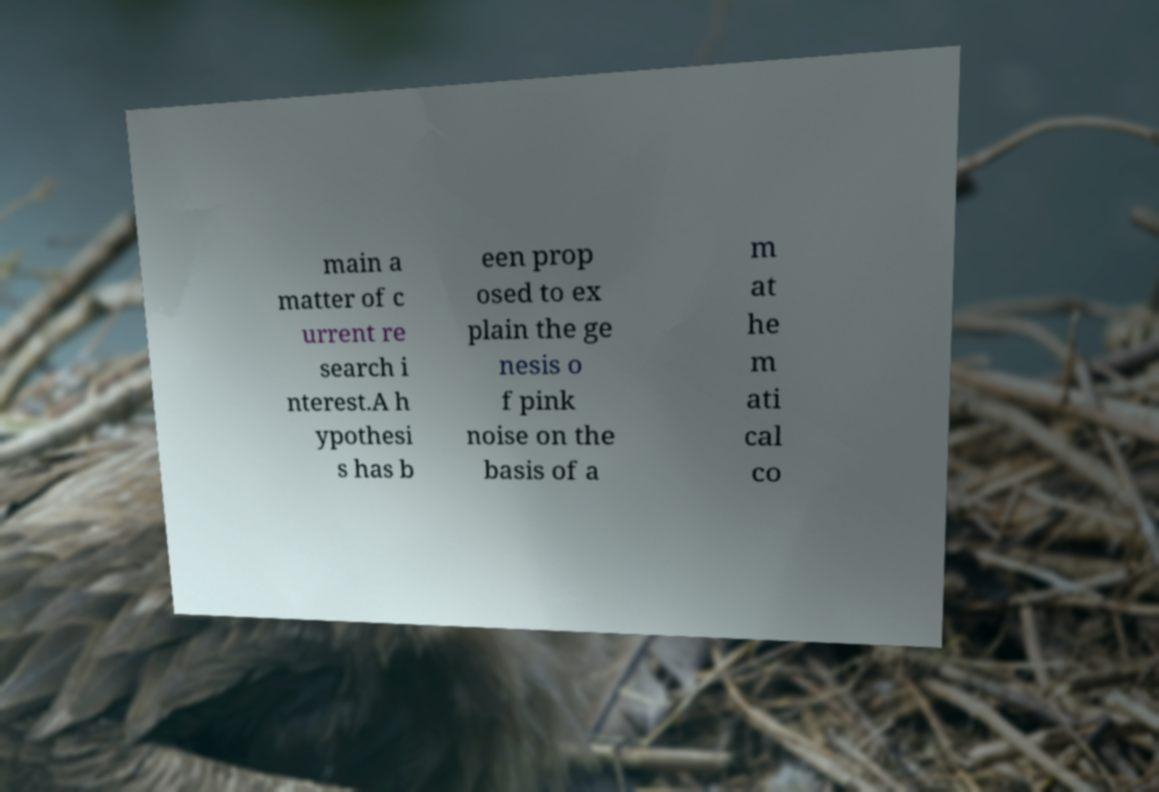What is pink noise and why is it significant in current research? Pink noise, also known as 1/f noise, is a signal or process with a frequency spectrum such that the power spectral density is inversely proportional to the frequency. It is significant in research because it appears in many physical, biological, and economic systems and can provide insights into their behavior and structure. 